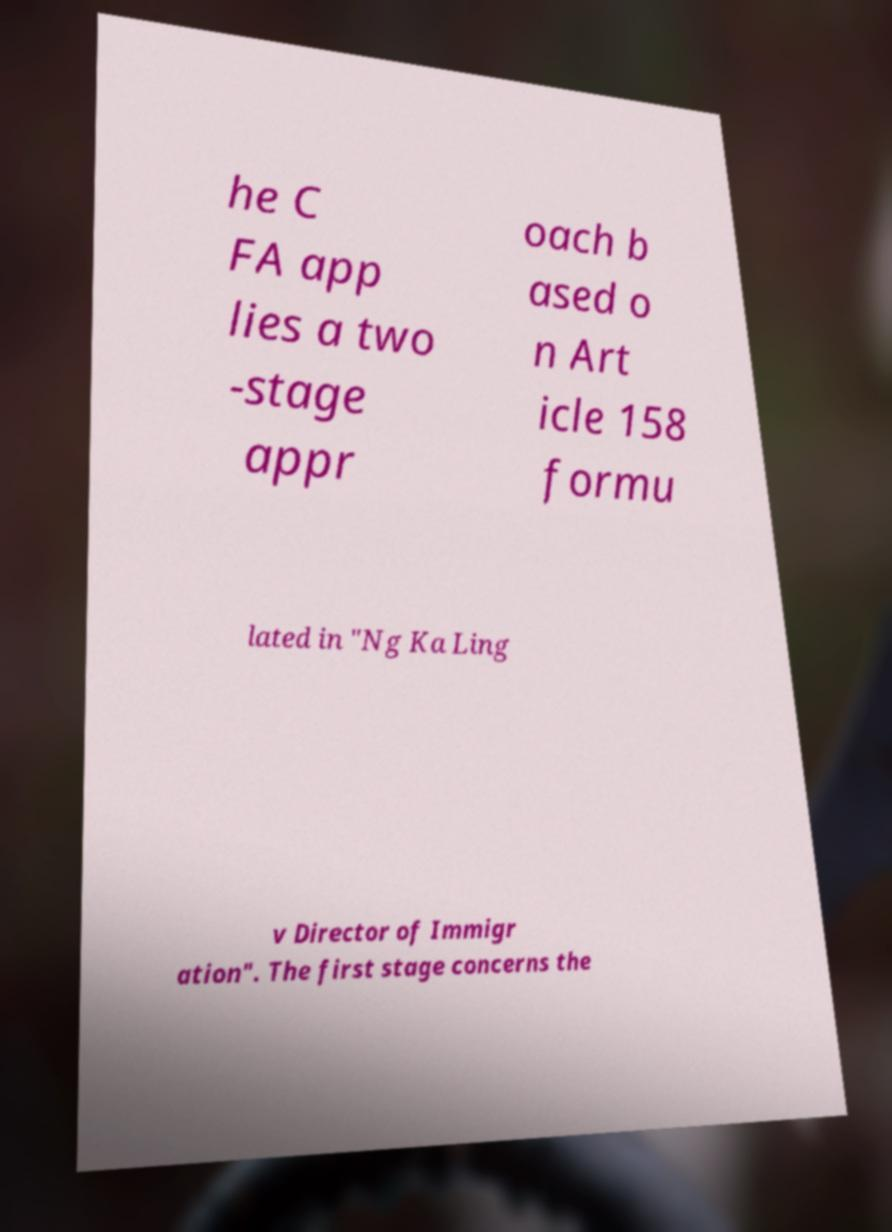Please read and relay the text visible in this image. What does it say? he C FA app lies a two -stage appr oach b ased o n Art icle 158 formu lated in "Ng Ka Ling v Director of Immigr ation". The first stage concerns the 